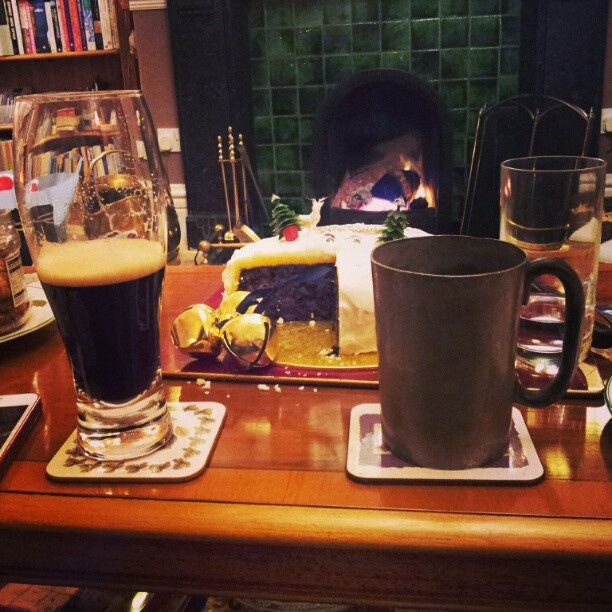Describe the objects in this image and their specific colors. I can see dining table in black, brown, red, and maroon tones, cup in black, brown, tan, and maroon tones, cup in black, maroon, and brown tones, cake in black, lightgray, tan, and purple tones, and cup in black, maroon, brown, and gray tones in this image. 